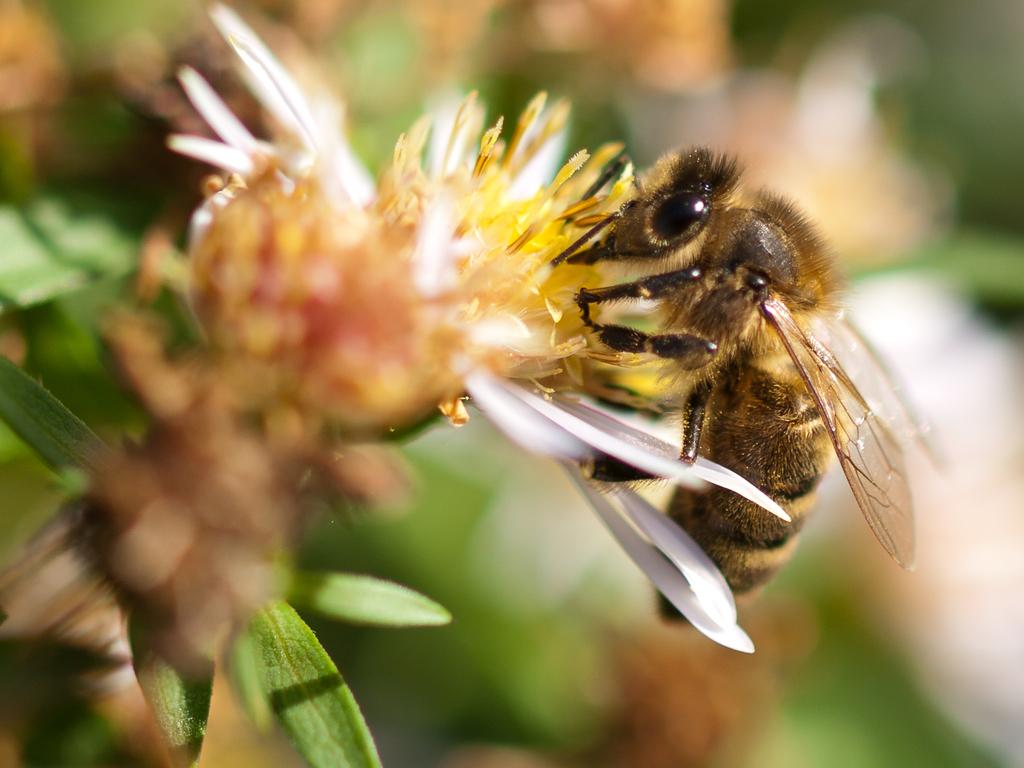What type of creature is in the image? There is an insect in the image. What colors can be seen on the insect? The insect has black and brown coloring. Where is the insect located in the image? The insect is on a flower. Can you describe the background of the image? The background of the image is blurred. What type of flavor can be tasted in the seashore depicted in the image? There is no seashore depicted in the image; it features an insect on a flower with a blurred background. 